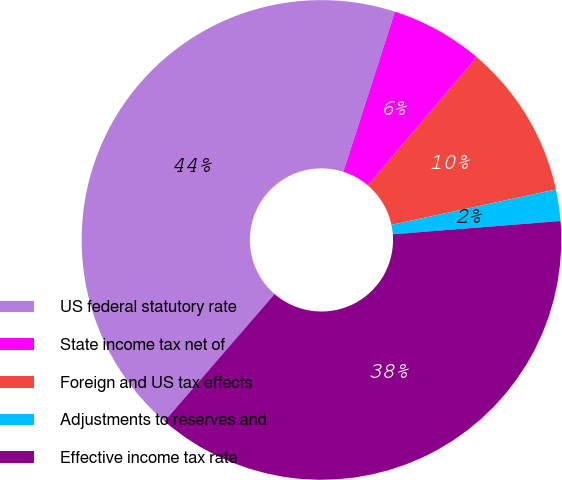Convert chart. <chart><loc_0><loc_0><loc_500><loc_500><pie_chart><fcel>US federal statutory rate<fcel>State income tax net of<fcel>Foreign and US tax effects<fcel>Adjustments to reserves and<fcel>Effective income tax rate<nl><fcel>43.59%<fcel>6.26%<fcel>10.41%<fcel>2.12%<fcel>37.61%<nl></chart> 